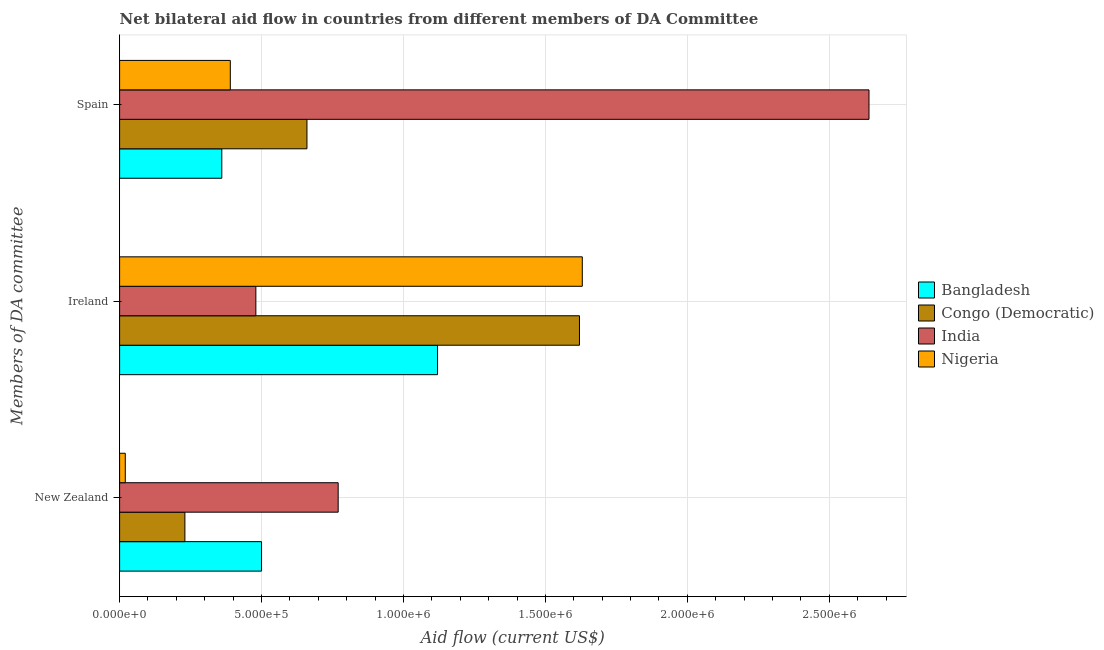Are the number of bars per tick equal to the number of legend labels?
Ensure brevity in your answer.  Yes. Are the number of bars on each tick of the Y-axis equal?
Offer a terse response. Yes. What is the label of the 1st group of bars from the top?
Your answer should be compact. Spain. What is the amount of aid provided by new zealand in India?
Your answer should be very brief. 7.70e+05. Across all countries, what is the maximum amount of aid provided by spain?
Keep it short and to the point. 2.64e+06. Across all countries, what is the minimum amount of aid provided by spain?
Your answer should be compact. 3.60e+05. In which country was the amount of aid provided by ireland maximum?
Keep it short and to the point. Nigeria. In which country was the amount of aid provided by new zealand minimum?
Provide a succinct answer. Nigeria. What is the total amount of aid provided by new zealand in the graph?
Provide a short and direct response. 1.52e+06. What is the difference between the amount of aid provided by new zealand in Nigeria and that in Congo (Democratic)?
Give a very brief answer. -2.10e+05. What is the difference between the amount of aid provided by new zealand in Bangladesh and the amount of aid provided by spain in India?
Your answer should be very brief. -2.14e+06. What is the average amount of aid provided by ireland per country?
Give a very brief answer. 1.21e+06. What is the difference between the amount of aid provided by spain and amount of aid provided by new zealand in Bangladesh?
Provide a succinct answer. -1.40e+05. What is the ratio of the amount of aid provided by ireland in Bangladesh to that in Nigeria?
Your answer should be compact. 0.69. What is the difference between the highest and the second highest amount of aid provided by new zealand?
Your answer should be very brief. 2.70e+05. What is the difference between the highest and the lowest amount of aid provided by spain?
Provide a succinct answer. 2.28e+06. Is the sum of the amount of aid provided by spain in Bangladesh and Nigeria greater than the maximum amount of aid provided by ireland across all countries?
Ensure brevity in your answer.  No. What does the 2nd bar from the top in Spain represents?
Your response must be concise. India. What does the 4th bar from the bottom in Ireland represents?
Ensure brevity in your answer.  Nigeria. Is it the case that in every country, the sum of the amount of aid provided by new zealand and amount of aid provided by ireland is greater than the amount of aid provided by spain?
Provide a short and direct response. No. Are all the bars in the graph horizontal?
Offer a terse response. Yes. How many countries are there in the graph?
Your response must be concise. 4. What is the difference between two consecutive major ticks on the X-axis?
Make the answer very short. 5.00e+05. Does the graph contain any zero values?
Your answer should be compact. No. Does the graph contain grids?
Provide a succinct answer. Yes. Where does the legend appear in the graph?
Ensure brevity in your answer.  Center right. What is the title of the graph?
Provide a succinct answer. Net bilateral aid flow in countries from different members of DA Committee. Does "Bahrain" appear as one of the legend labels in the graph?
Your answer should be very brief. No. What is the label or title of the Y-axis?
Provide a short and direct response. Members of DA committee. What is the Aid flow (current US$) in India in New Zealand?
Offer a terse response. 7.70e+05. What is the Aid flow (current US$) of Nigeria in New Zealand?
Your answer should be very brief. 2.00e+04. What is the Aid flow (current US$) of Bangladesh in Ireland?
Offer a terse response. 1.12e+06. What is the Aid flow (current US$) of Congo (Democratic) in Ireland?
Offer a terse response. 1.62e+06. What is the Aid flow (current US$) in Nigeria in Ireland?
Offer a very short reply. 1.63e+06. What is the Aid flow (current US$) in Bangladesh in Spain?
Provide a short and direct response. 3.60e+05. What is the Aid flow (current US$) in India in Spain?
Provide a short and direct response. 2.64e+06. Across all Members of DA committee, what is the maximum Aid flow (current US$) in Bangladesh?
Your answer should be compact. 1.12e+06. Across all Members of DA committee, what is the maximum Aid flow (current US$) in Congo (Democratic)?
Make the answer very short. 1.62e+06. Across all Members of DA committee, what is the maximum Aid flow (current US$) of India?
Give a very brief answer. 2.64e+06. Across all Members of DA committee, what is the maximum Aid flow (current US$) of Nigeria?
Make the answer very short. 1.63e+06. Across all Members of DA committee, what is the minimum Aid flow (current US$) in India?
Give a very brief answer. 4.80e+05. Across all Members of DA committee, what is the minimum Aid flow (current US$) in Nigeria?
Your answer should be compact. 2.00e+04. What is the total Aid flow (current US$) of Bangladesh in the graph?
Ensure brevity in your answer.  1.98e+06. What is the total Aid flow (current US$) of Congo (Democratic) in the graph?
Give a very brief answer. 2.51e+06. What is the total Aid flow (current US$) in India in the graph?
Give a very brief answer. 3.89e+06. What is the total Aid flow (current US$) in Nigeria in the graph?
Your answer should be very brief. 2.04e+06. What is the difference between the Aid flow (current US$) in Bangladesh in New Zealand and that in Ireland?
Give a very brief answer. -6.20e+05. What is the difference between the Aid flow (current US$) of Congo (Democratic) in New Zealand and that in Ireland?
Your answer should be very brief. -1.39e+06. What is the difference between the Aid flow (current US$) of Nigeria in New Zealand and that in Ireland?
Offer a very short reply. -1.61e+06. What is the difference between the Aid flow (current US$) in Bangladesh in New Zealand and that in Spain?
Ensure brevity in your answer.  1.40e+05. What is the difference between the Aid flow (current US$) in Congo (Democratic) in New Zealand and that in Spain?
Offer a terse response. -4.30e+05. What is the difference between the Aid flow (current US$) in India in New Zealand and that in Spain?
Make the answer very short. -1.87e+06. What is the difference between the Aid flow (current US$) in Nigeria in New Zealand and that in Spain?
Your answer should be compact. -3.70e+05. What is the difference between the Aid flow (current US$) of Bangladesh in Ireland and that in Spain?
Ensure brevity in your answer.  7.60e+05. What is the difference between the Aid flow (current US$) of Congo (Democratic) in Ireland and that in Spain?
Provide a succinct answer. 9.60e+05. What is the difference between the Aid flow (current US$) in India in Ireland and that in Spain?
Ensure brevity in your answer.  -2.16e+06. What is the difference between the Aid flow (current US$) of Nigeria in Ireland and that in Spain?
Your response must be concise. 1.24e+06. What is the difference between the Aid flow (current US$) in Bangladesh in New Zealand and the Aid flow (current US$) in Congo (Democratic) in Ireland?
Your response must be concise. -1.12e+06. What is the difference between the Aid flow (current US$) of Bangladesh in New Zealand and the Aid flow (current US$) of India in Ireland?
Make the answer very short. 2.00e+04. What is the difference between the Aid flow (current US$) of Bangladesh in New Zealand and the Aid flow (current US$) of Nigeria in Ireland?
Offer a very short reply. -1.13e+06. What is the difference between the Aid flow (current US$) of Congo (Democratic) in New Zealand and the Aid flow (current US$) of India in Ireland?
Your response must be concise. -2.50e+05. What is the difference between the Aid flow (current US$) of Congo (Democratic) in New Zealand and the Aid flow (current US$) of Nigeria in Ireland?
Your response must be concise. -1.40e+06. What is the difference between the Aid flow (current US$) in India in New Zealand and the Aid flow (current US$) in Nigeria in Ireland?
Make the answer very short. -8.60e+05. What is the difference between the Aid flow (current US$) of Bangladesh in New Zealand and the Aid flow (current US$) of Congo (Democratic) in Spain?
Make the answer very short. -1.60e+05. What is the difference between the Aid flow (current US$) of Bangladesh in New Zealand and the Aid flow (current US$) of India in Spain?
Provide a succinct answer. -2.14e+06. What is the difference between the Aid flow (current US$) of Congo (Democratic) in New Zealand and the Aid flow (current US$) of India in Spain?
Your response must be concise. -2.41e+06. What is the difference between the Aid flow (current US$) of Bangladesh in Ireland and the Aid flow (current US$) of India in Spain?
Make the answer very short. -1.52e+06. What is the difference between the Aid flow (current US$) of Bangladesh in Ireland and the Aid flow (current US$) of Nigeria in Spain?
Your response must be concise. 7.30e+05. What is the difference between the Aid flow (current US$) in Congo (Democratic) in Ireland and the Aid flow (current US$) in India in Spain?
Your answer should be very brief. -1.02e+06. What is the difference between the Aid flow (current US$) of Congo (Democratic) in Ireland and the Aid flow (current US$) of Nigeria in Spain?
Your answer should be very brief. 1.23e+06. What is the difference between the Aid flow (current US$) of India in Ireland and the Aid flow (current US$) of Nigeria in Spain?
Make the answer very short. 9.00e+04. What is the average Aid flow (current US$) of Bangladesh per Members of DA committee?
Provide a succinct answer. 6.60e+05. What is the average Aid flow (current US$) of Congo (Democratic) per Members of DA committee?
Your response must be concise. 8.37e+05. What is the average Aid flow (current US$) of India per Members of DA committee?
Offer a very short reply. 1.30e+06. What is the average Aid flow (current US$) of Nigeria per Members of DA committee?
Provide a short and direct response. 6.80e+05. What is the difference between the Aid flow (current US$) in Bangladesh and Aid flow (current US$) in India in New Zealand?
Offer a very short reply. -2.70e+05. What is the difference between the Aid flow (current US$) of Congo (Democratic) and Aid flow (current US$) of India in New Zealand?
Offer a terse response. -5.40e+05. What is the difference between the Aid flow (current US$) of Congo (Democratic) and Aid flow (current US$) of Nigeria in New Zealand?
Provide a short and direct response. 2.10e+05. What is the difference between the Aid flow (current US$) of India and Aid flow (current US$) of Nigeria in New Zealand?
Give a very brief answer. 7.50e+05. What is the difference between the Aid flow (current US$) of Bangladesh and Aid flow (current US$) of Congo (Democratic) in Ireland?
Your answer should be very brief. -5.00e+05. What is the difference between the Aid flow (current US$) in Bangladesh and Aid flow (current US$) in India in Ireland?
Make the answer very short. 6.40e+05. What is the difference between the Aid flow (current US$) of Bangladesh and Aid flow (current US$) of Nigeria in Ireland?
Offer a terse response. -5.10e+05. What is the difference between the Aid flow (current US$) of Congo (Democratic) and Aid flow (current US$) of India in Ireland?
Provide a succinct answer. 1.14e+06. What is the difference between the Aid flow (current US$) in Congo (Democratic) and Aid flow (current US$) in Nigeria in Ireland?
Give a very brief answer. -10000. What is the difference between the Aid flow (current US$) of India and Aid flow (current US$) of Nigeria in Ireland?
Your answer should be compact. -1.15e+06. What is the difference between the Aid flow (current US$) of Bangladesh and Aid flow (current US$) of Congo (Democratic) in Spain?
Provide a short and direct response. -3.00e+05. What is the difference between the Aid flow (current US$) in Bangladesh and Aid flow (current US$) in India in Spain?
Your answer should be compact. -2.28e+06. What is the difference between the Aid flow (current US$) of Congo (Democratic) and Aid flow (current US$) of India in Spain?
Ensure brevity in your answer.  -1.98e+06. What is the difference between the Aid flow (current US$) in India and Aid flow (current US$) in Nigeria in Spain?
Your answer should be compact. 2.25e+06. What is the ratio of the Aid flow (current US$) in Bangladesh in New Zealand to that in Ireland?
Ensure brevity in your answer.  0.45. What is the ratio of the Aid flow (current US$) of Congo (Democratic) in New Zealand to that in Ireland?
Make the answer very short. 0.14. What is the ratio of the Aid flow (current US$) in India in New Zealand to that in Ireland?
Your response must be concise. 1.6. What is the ratio of the Aid flow (current US$) of Nigeria in New Zealand to that in Ireland?
Offer a terse response. 0.01. What is the ratio of the Aid flow (current US$) of Bangladesh in New Zealand to that in Spain?
Your response must be concise. 1.39. What is the ratio of the Aid flow (current US$) in Congo (Democratic) in New Zealand to that in Spain?
Keep it short and to the point. 0.35. What is the ratio of the Aid flow (current US$) of India in New Zealand to that in Spain?
Offer a very short reply. 0.29. What is the ratio of the Aid flow (current US$) in Nigeria in New Zealand to that in Spain?
Make the answer very short. 0.05. What is the ratio of the Aid flow (current US$) of Bangladesh in Ireland to that in Spain?
Provide a succinct answer. 3.11. What is the ratio of the Aid flow (current US$) of Congo (Democratic) in Ireland to that in Spain?
Make the answer very short. 2.45. What is the ratio of the Aid flow (current US$) in India in Ireland to that in Spain?
Keep it short and to the point. 0.18. What is the ratio of the Aid flow (current US$) in Nigeria in Ireland to that in Spain?
Your answer should be compact. 4.18. What is the difference between the highest and the second highest Aid flow (current US$) in Bangladesh?
Provide a succinct answer. 6.20e+05. What is the difference between the highest and the second highest Aid flow (current US$) in Congo (Democratic)?
Ensure brevity in your answer.  9.60e+05. What is the difference between the highest and the second highest Aid flow (current US$) of India?
Offer a terse response. 1.87e+06. What is the difference between the highest and the second highest Aid flow (current US$) in Nigeria?
Provide a short and direct response. 1.24e+06. What is the difference between the highest and the lowest Aid flow (current US$) in Bangladesh?
Your response must be concise. 7.60e+05. What is the difference between the highest and the lowest Aid flow (current US$) of Congo (Democratic)?
Your answer should be very brief. 1.39e+06. What is the difference between the highest and the lowest Aid flow (current US$) of India?
Offer a terse response. 2.16e+06. What is the difference between the highest and the lowest Aid flow (current US$) of Nigeria?
Make the answer very short. 1.61e+06. 